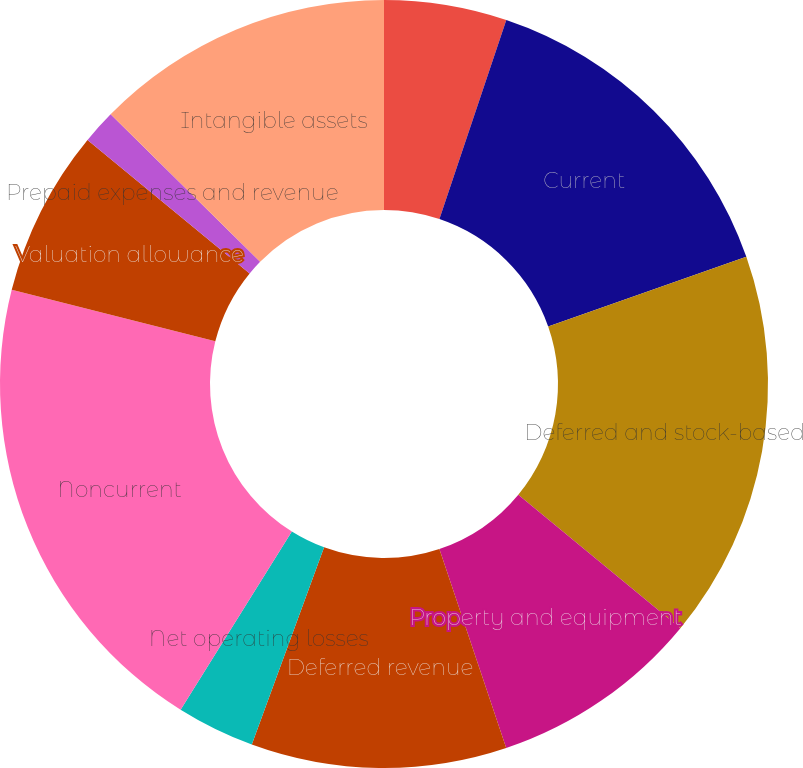<chart> <loc_0><loc_0><loc_500><loc_500><pie_chart><fcel>Allowance for credit losses<fcel>Current<fcel>Deferred and stock-based<fcel>Property and equipment<fcel>Deferred revenue<fcel>Net operating losses<fcel>Noncurrent<fcel>Valuation allowance<fcel>Prepaid expenses and revenue<fcel>Intangible assets<nl><fcel>5.16%<fcel>14.47%<fcel>16.34%<fcel>8.88%<fcel>10.75%<fcel>3.29%<fcel>20.06%<fcel>7.02%<fcel>1.43%<fcel>12.61%<nl></chart> 